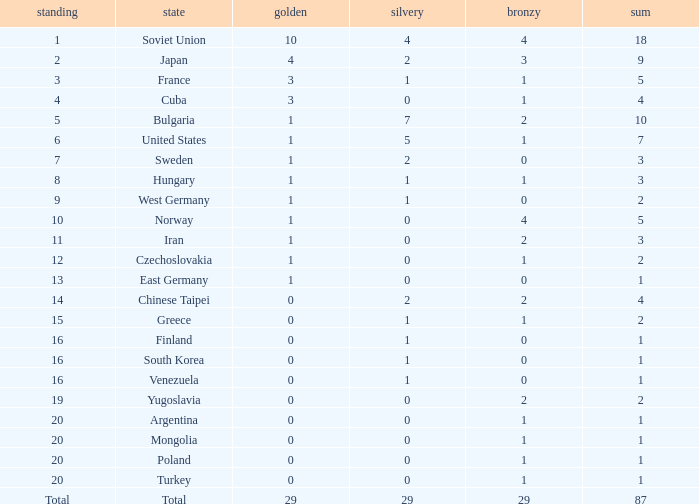What is the sum of gold medals for a rank of 14? 0.0. 